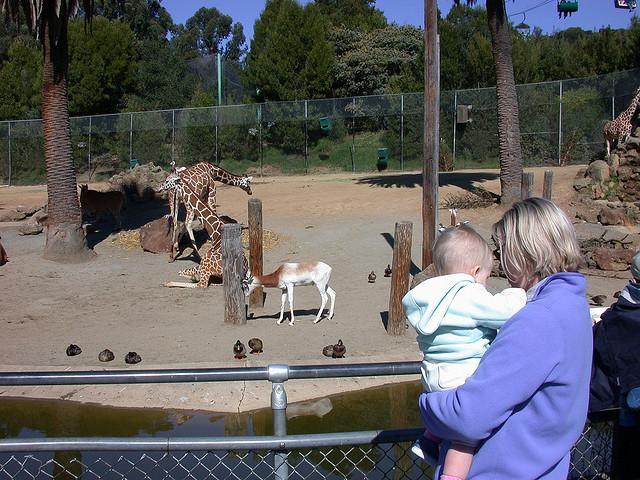What are the birds in the pen called?

Choices:
A) storks
B) pelicans
C) ducks
D) flamingos ducks 